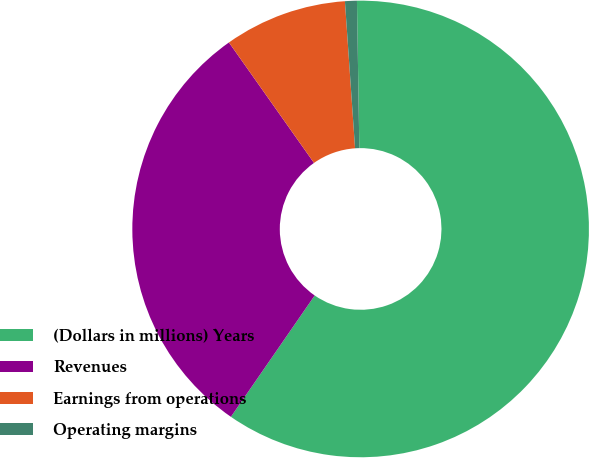Convert chart to OTSL. <chart><loc_0><loc_0><loc_500><loc_500><pie_chart><fcel>(Dollars in millions) Years<fcel>Revenues<fcel>Earnings from operations<fcel>Operating margins<nl><fcel>59.88%<fcel>30.6%<fcel>8.69%<fcel>0.84%<nl></chart> 